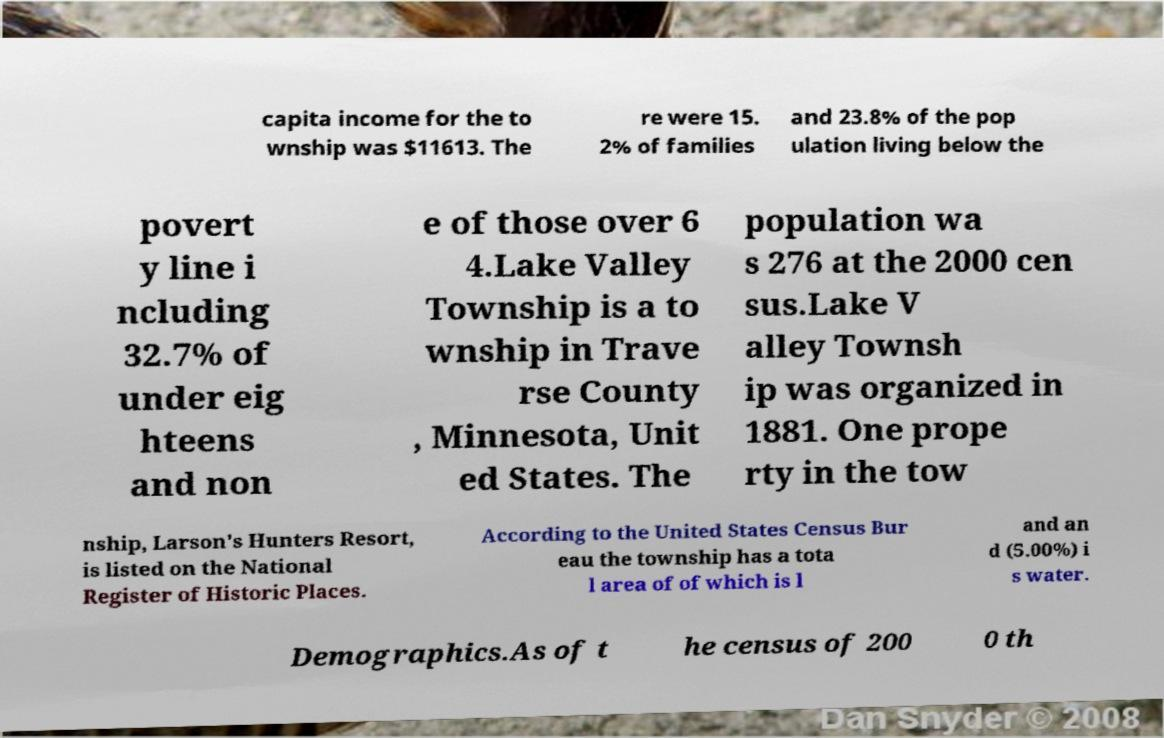I need the written content from this picture converted into text. Can you do that? capita income for the to wnship was $11613. The re were 15. 2% of families and 23.8% of the pop ulation living below the povert y line i ncluding 32.7% of under eig hteens and non e of those over 6 4.Lake Valley Township is a to wnship in Trave rse County , Minnesota, Unit ed States. The population wa s 276 at the 2000 cen sus.Lake V alley Townsh ip was organized in 1881. One prope rty in the tow nship, Larson's Hunters Resort, is listed on the National Register of Historic Places. According to the United States Census Bur eau the township has a tota l area of of which is l and an d (5.00%) i s water. Demographics.As of t he census of 200 0 th 